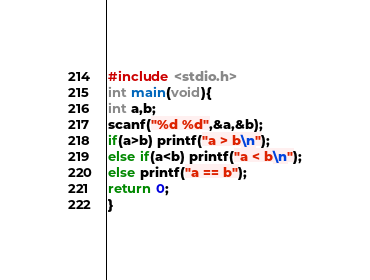Convert code to text. <code><loc_0><loc_0><loc_500><loc_500><_C_>#include <stdio.h>
int main(void){
int a,b;
scanf("%d %d",&a,&b);
if(a>b) printf("a > b\n");
else if(a<b) printf("a < b\n");
else printf("a == b");
return 0;
}</code> 